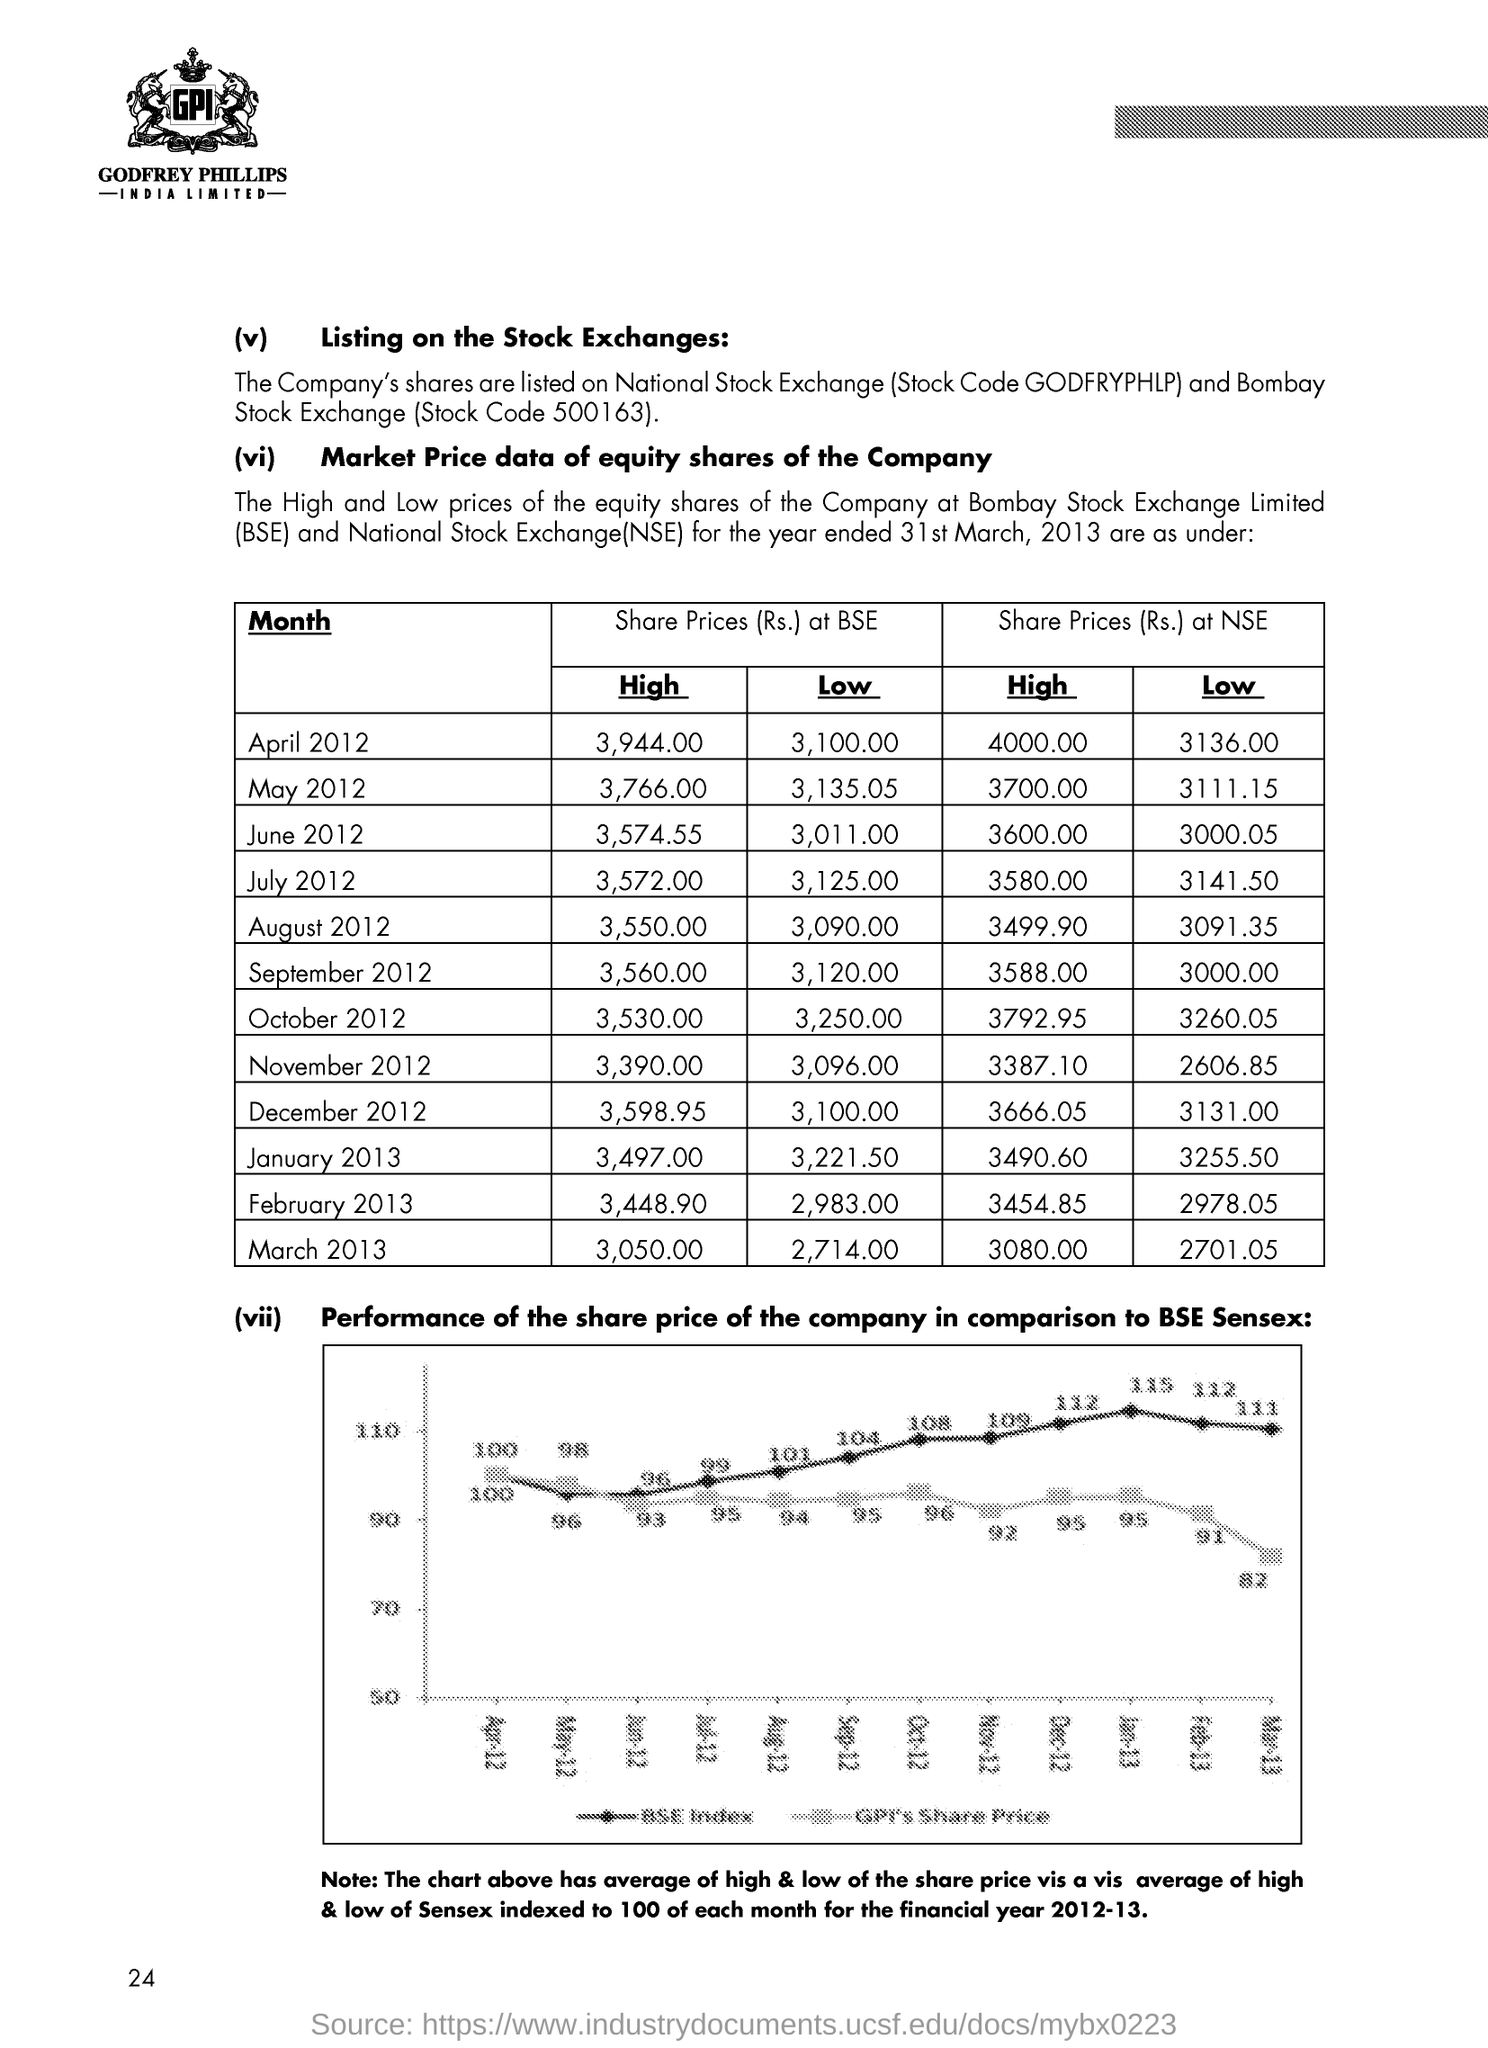What is the fullform of NSE?
Offer a very short reply. National Stock Exchange. 